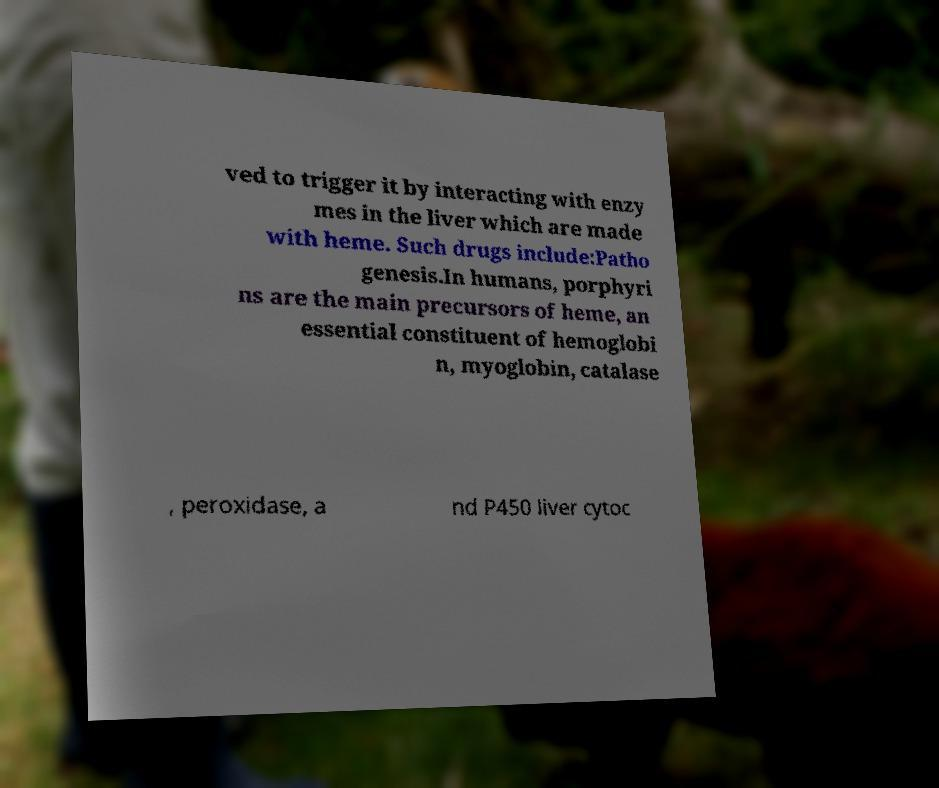Could you assist in decoding the text presented in this image and type it out clearly? ved to trigger it by interacting with enzy mes in the liver which are made with heme. Such drugs include:Patho genesis.In humans, porphyri ns are the main precursors of heme, an essential constituent of hemoglobi n, myoglobin, catalase , peroxidase, a nd P450 liver cytoc 